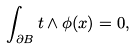Convert formula to latex. <formula><loc_0><loc_0><loc_500><loc_500>\int _ { \partial B } t \wedge \phi ( x ) = 0 ,</formula> 